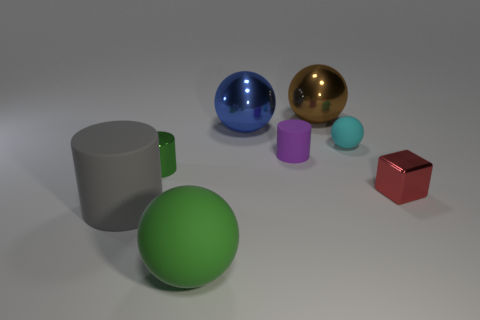Is the number of rubber objects that are left of the blue sphere less than the number of large gray matte things behind the tiny rubber cylinder?
Offer a very short reply. No. What number of small brown cylinders are the same material as the big green object?
Your answer should be compact. 0. Does the green metal cylinder have the same size as the rubber cylinder on the right side of the blue object?
Your answer should be very brief. Yes. There is a thing that is the same color as the large matte sphere; what is its material?
Your response must be concise. Metal. What is the size of the green object behind the red metal thing that is on the right side of the large blue object in front of the brown metal ball?
Your answer should be compact. Small. Is the number of metallic cubes behind the red block greater than the number of gray things that are to the left of the tiny rubber sphere?
Your answer should be very brief. No. There is a shiny object behind the big blue ball; what number of red objects are in front of it?
Make the answer very short. 1. Are there any rubber cubes of the same color as the shiny cylinder?
Make the answer very short. No. Is the size of the metallic cube the same as the green metal thing?
Your response must be concise. Yes. Does the tiny shiny cylinder have the same color as the tiny matte cylinder?
Provide a short and direct response. No. 